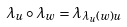Convert formula to latex. <formula><loc_0><loc_0><loc_500><loc_500>\lambda _ { u } \circ \lambda _ { w } = \lambda _ { \lambda _ { u } ( w ) u }</formula> 